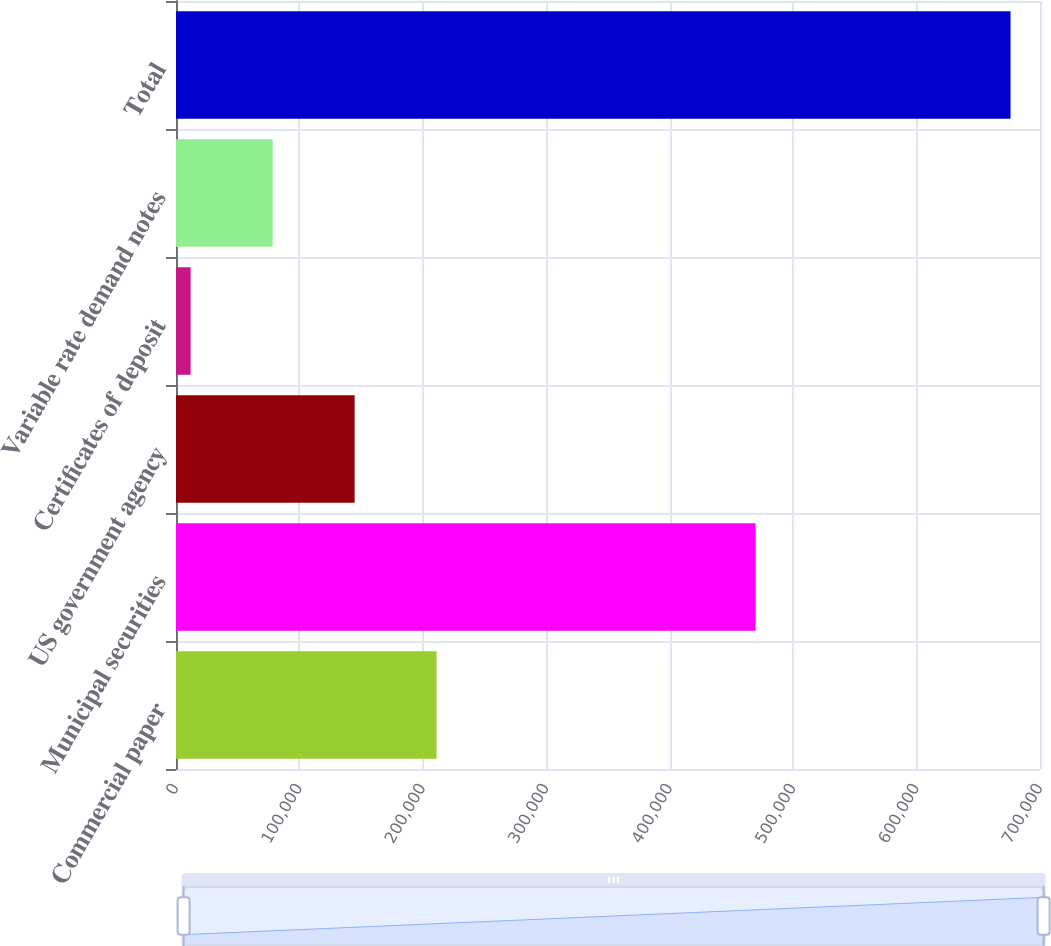<chart> <loc_0><loc_0><loc_500><loc_500><bar_chart><fcel>Commercial paper<fcel>Municipal securities<fcel>US government agency<fcel>Certificates of deposit<fcel>Variable rate demand notes<fcel>Total<nl><fcel>211147<fcel>469604<fcel>144721<fcel>11869<fcel>78295<fcel>676129<nl></chart> 